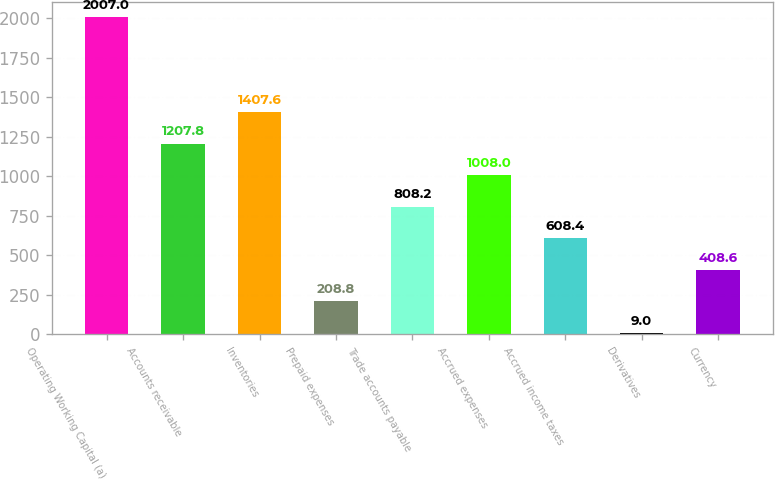Convert chart. <chart><loc_0><loc_0><loc_500><loc_500><bar_chart><fcel>Operating Working Capital (a)<fcel>Accounts receivable<fcel>Inventories<fcel>Prepaid expenses<fcel>Trade accounts payable<fcel>Accrued expenses<fcel>Accrued income taxes<fcel>Derivatives<fcel>Currency<nl><fcel>2007<fcel>1207.8<fcel>1407.6<fcel>208.8<fcel>808.2<fcel>1008<fcel>608.4<fcel>9<fcel>408.6<nl></chart> 